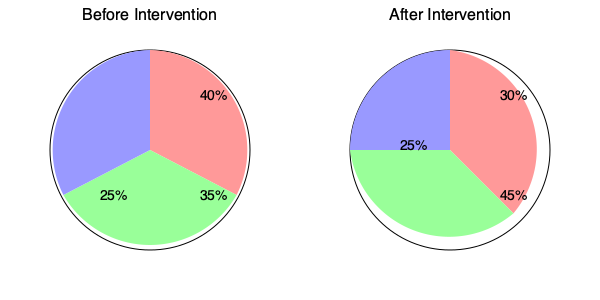Based on the before-and-after pie charts showing the distribution of healthcare access in a community, calculate the percent change in the proportion of the population with moderate access (green segment) following the intervention. What does this result suggest about the effectiveness of the intervention strategy? To evaluate the effectiveness of the intervention strategy, we need to calculate the percent change in the proportion of the population with moderate access (green segment) and interpret the result. Let's follow these steps:

1. Identify the proportion with moderate access before the intervention:
   Before intervention: 35%

2. Identify the proportion with moderate access after the intervention:
   After intervention: 45%

3. Calculate the absolute change:
   $45\% - 35\% = 10\%$ increase

4. Calculate the percent change using the formula:
   $\text{Percent Change} = \frac{\text{New Value} - \text{Original Value}}{\text{Original Value}} \times 100\%$

   $\text{Percent Change} = \frac{45\% - 35\%}{35\%} \times 100\%$
   $= \frac{10\%}{35\%} \times 100\%$
   $= 0.2857 \times 100\%$
   $= 28.57\%$

5. Interpret the result:
   The proportion of the population with moderate access to healthcare increased by 28.57% following the intervention.

This substantial increase suggests that the intervention strategy was effective in improving healthcare access for a significant portion of the community. The strategy appears to have successfully shifted some individuals from the low access category (red segment, which decreased from 40% to 30%) to the moderate access category.

However, it's important to note that the high access category (blue segment) remained unchanged at 25%, indicating that the intervention may not have been as effective in moving individuals to the highest level of access. This insight could be valuable for refining future intervention strategies to target improvements across all levels of healthcare access.
Answer: 28.57% increase; intervention was effective in improving moderate access but did not impact high access. 